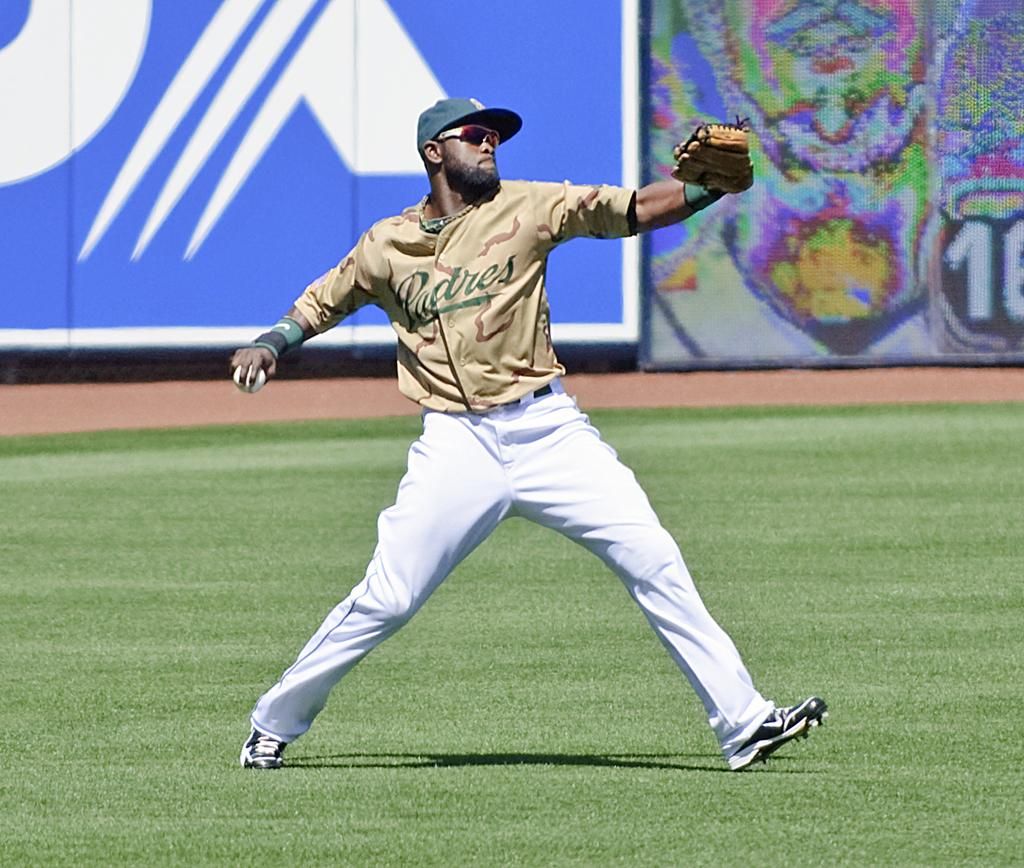<image>
Offer a succinct explanation of the picture presented. A baseball player wearing a Padres jersey is throwing a baseball. 